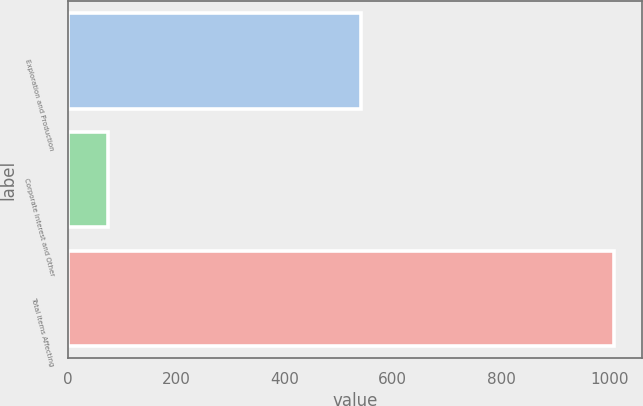Convert chart. <chart><loc_0><loc_0><loc_500><loc_500><bar_chart><fcel>Exploration and Production<fcel>Corporate Interest and Other<fcel>Total Items Affecting<nl><fcel>542<fcel>74<fcel>1009<nl></chart> 